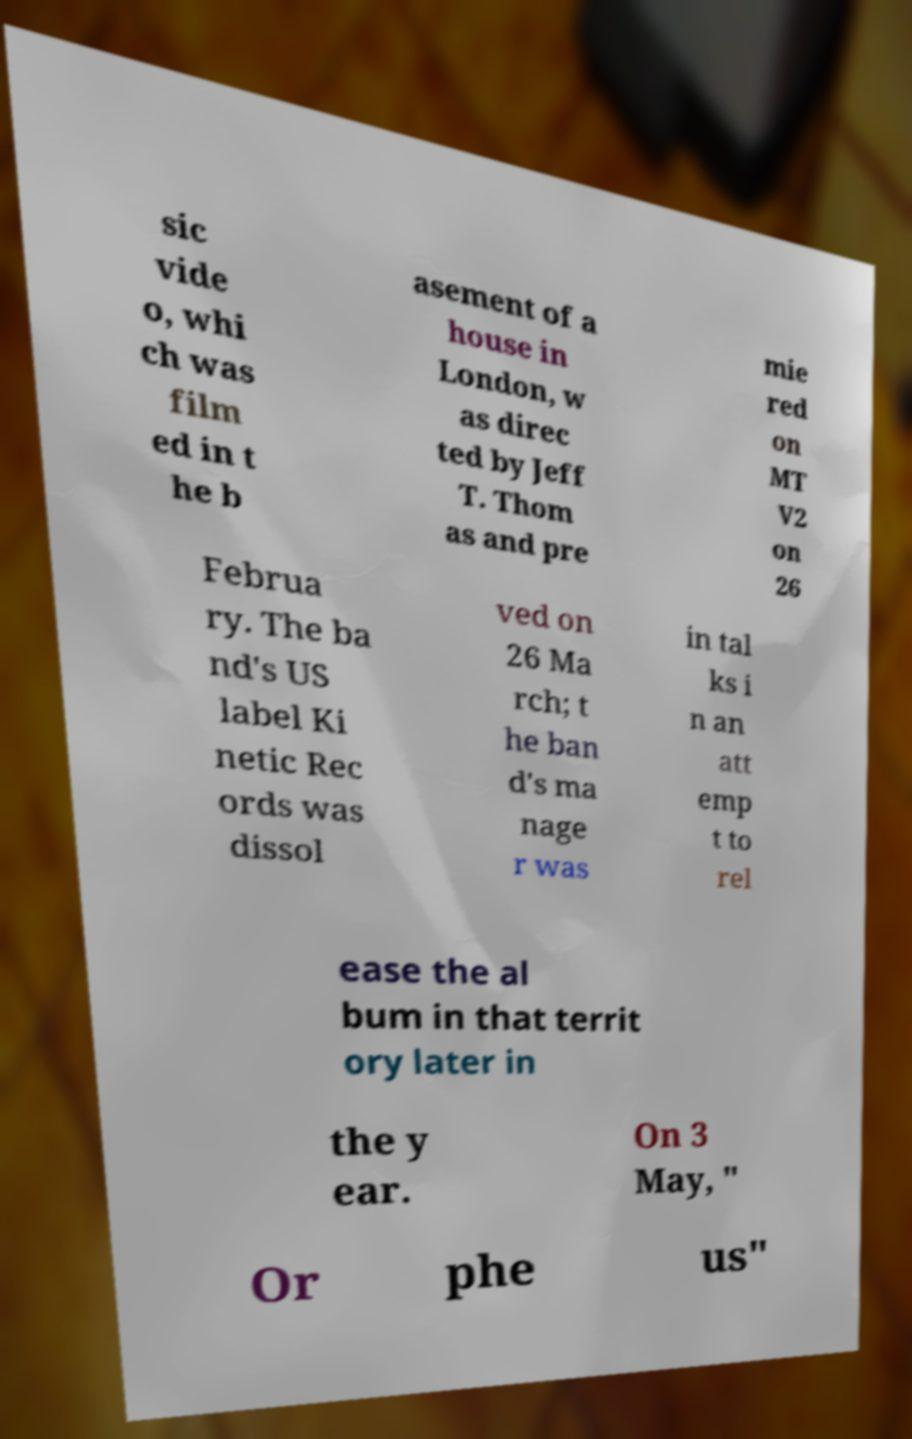Could you extract and type out the text from this image? sic vide o, whi ch was film ed in t he b asement of a house in London, w as direc ted by Jeff T. Thom as and pre mie red on MT V2 on 26 Februa ry. The ba nd's US label Ki netic Rec ords was dissol ved on 26 Ma rch; t he ban d's ma nage r was in tal ks i n an att emp t to rel ease the al bum in that territ ory later in the y ear. On 3 May, " Or phe us" 